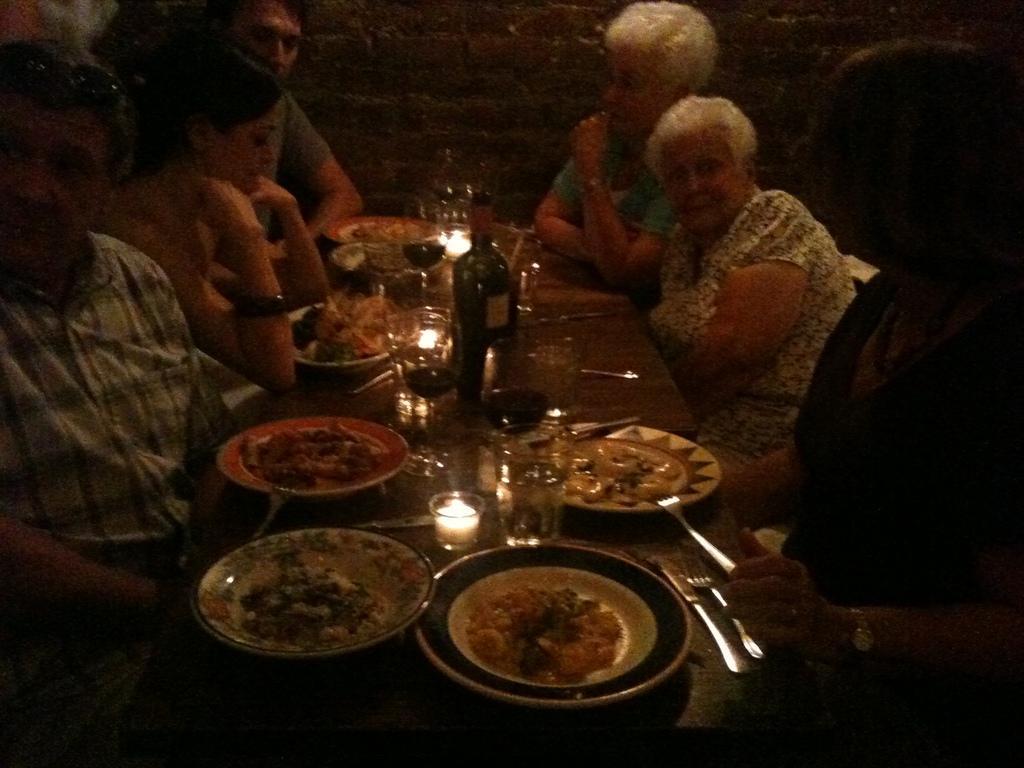Can you describe this image briefly? In this picture there is a table in the center of the image, on which there are plates, glasses, spoons, food items, and a bottle on it, there are people those who are sitting around the table. 